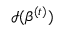<formula> <loc_0><loc_0><loc_500><loc_500>{ \mathcal { I } } ( { \beta } ^ { ( t ) } )</formula> 